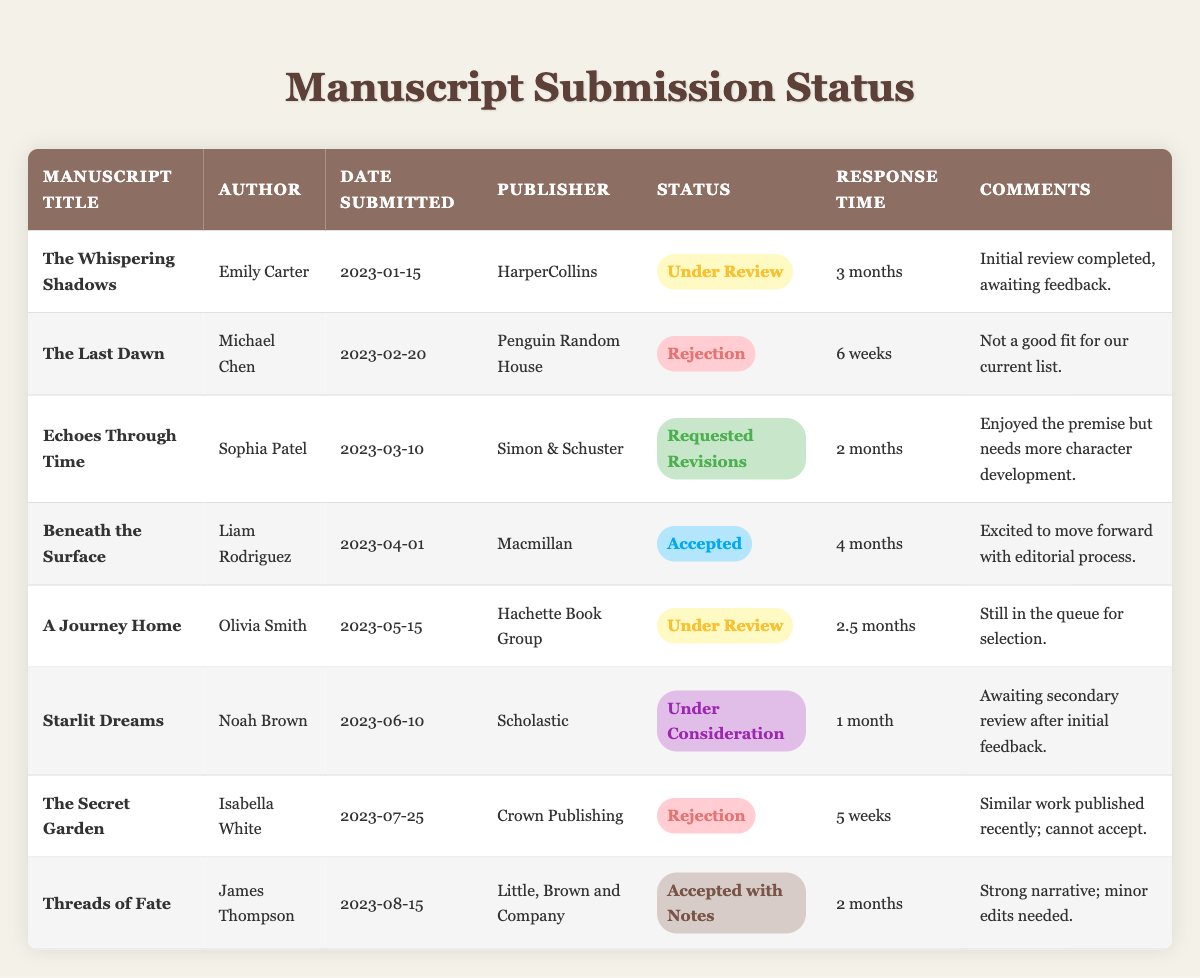What is the status of "The Whispering Shadows"? By looking at the table, I can see that the status for "The Whispering Shadows" is marked as "Under Review."
Answer: Under Review How many manuscripts have been rejected? There are two instances of rejection in the status column: "The Last Dawn" and "The Secret Garden." Thus, the total count is 2.
Answer: 2 What is the response time for "Echoes Through Time"? The table shows that the response time for "Echoes Through Time" is 2 months.
Answer: 2 months Which manuscript received a status of "Accepted"? From the table, "Beneath the Surface" is the manuscript that has the status of "Accepted."
Answer: Beneath the Surface What is the average response time for all manuscripts? To find the average response time, I total the response times calculated in weeks (3 months = 12 weeks, 6 weeks, 2 months = 8 weeks, 4 months = 16 weeks, 2.5 months = 10 weeks, 1 month = 4 weeks, 5 weeks, 2 months = 8 weeks). This sums to 66 weeks. Since there are 8 manuscripts, the average response time is 66 weeks / 8 = 8.25 weeks, which is approximately 8 weeks and 2 days.
Answer: 8 weeks and 2 days Is "Threads of Fate" accepted with notes? Looking at the table, the status for "Threads of Fate" is indeed "Accepted with Notes," which confirms the fact.
Answer: Yes What is the publisher for the manuscript that is currently under consideration? The table states that the manuscript "Starlit Dreams" is under consideration, and its publisher is Scholastic.
Answer: Scholastic Which author submitted the manuscript with the longest response time? The longest response time is for "The Whispering Shadows," which is 3 months (12 weeks). Comparing all response times shows this is the longest, attributed to author Emily Carter.
Answer: Emily Carter How many manuscripts are currently under review? "The Whispering Shadows" and "A Journey Home" are both under review, so the total count is 2.
Answer: 2 What comments were made on the manuscript "Threads of Fate"? The comments for "Threads of Fate" state it has a strong narrative but requires minor edits.
Answer: Strong narrative; minor edits needed Is there any manuscript with a response time of exactly 1 month? Yes, the manuscript "Starlit Dreams" has a response time of exactly 1 month.
Answer: Yes 